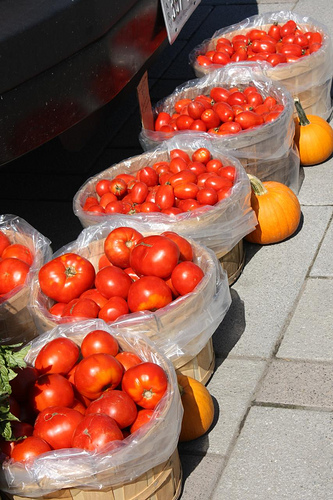<image>
Is there a tomato in the basket? No. The tomato is not contained within the basket. These objects have a different spatial relationship. Is the tomato in the basket? No. The tomato is not contained within the basket. These objects have a different spatial relationship. 